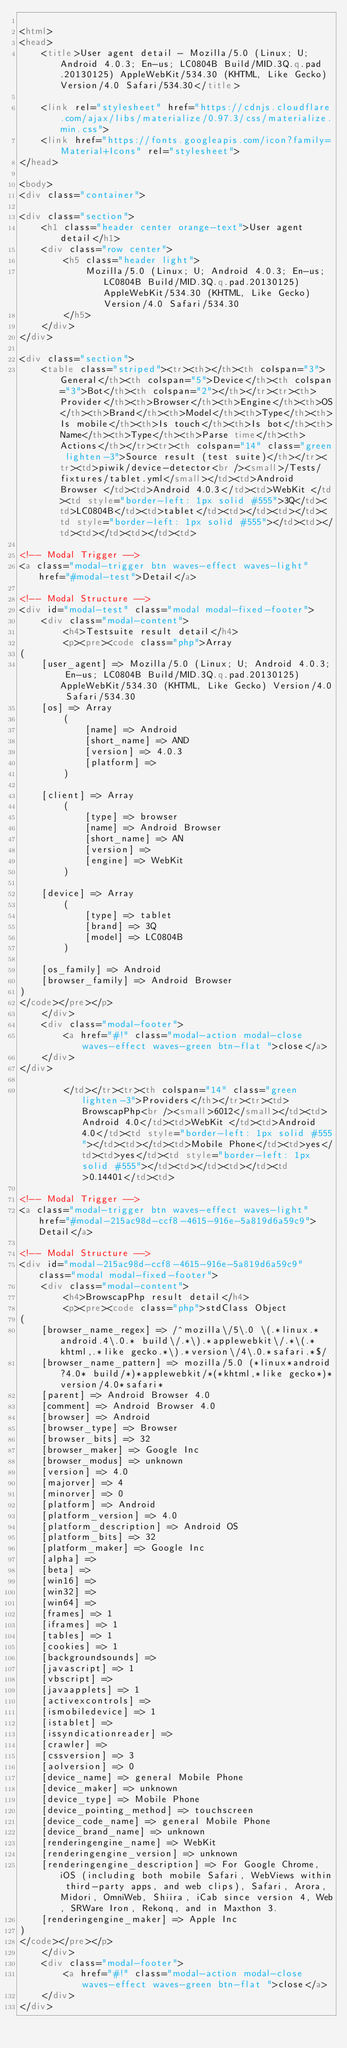<code> <loc_0><loc_0><loc_500><loc_500><_HTML_>
<html>
<head>
    <title>User agent detail - Mozilla/5.0 (Linux; U; Android 4.0.3; En-us; LC0804B Build/MID.3Q.q.pad.20130125) AppleWebKit/534.30 (KHTML, Like Gecko) Version/4.0 Safari/534.30</title>
        
    <link rel="stylesheet" href="https://cdnjs.cloudflare.com/ajax/libs/materialize/0.97.3/css/materialize.min.css">
    <link href="https://fonts.googleapis.com/icon?family=Material+Icons" rel="stylesheet">
</head>
        
<body>
<div class="container">
    
<div class="section">
	<h1 class="header center orange-text">User agent detail</h1>
	<div class="row center">
        <h5 class="header light">
            Mozilla/5.0 (Linux; U; Android 4.0.3; En-us; LC0804B Build/MID.3Q.q.pad.20130125) AppleWebKit/534.30 (KHTML, Like Gecko) Version/4.0 Safari/534.30
        </h5>
	</div>
</div>   

<div class="section">
    <table class="striped"><tr><th></th><th colspan="3">General</th><th colspan="5">Device</th><th colspan="3">Bot</th><th colspan="2"></th></tr><tr><th>Provider</th><th>Browser</th><th>Engine</th><th>OS</th><th>Brand</th><th>Model</th><th>Type</th><th>Is mobile</th><th>Is touch</th><th>Is bot</th><th>Name</th><th>Type</th><th>Parse time</th><th>Actions</th></tr><tr><th colspan="14" class="green lighten-3">Source result (test suite)</th></tr><tr><td>piwik/device-detector<br /><small>/Tests/fixtures/tablet.yml</small></td><td>Android Browser </td><td>Android 4.0.3</td><td>WebKit </td><td style="border-left: 1px solid #555">3Q</td><td>LC0804B</td><td>tablet</td><td></td><td></td><td style="border-left: 1px solid #555"></td><td></td><td></td><td></td><td>
                
<!-- Modal Trigger -->
<a class="modal-trigger btn waves-effect waves-light" href="#modal-test">Detail</a>

<!-- Modal Structure -->
<div id="modal-test" class="modal modal-fixed-footer">
    <div class="modal-content">
        <h4>Testsuite result detail</h4>
        <p><pre><code class="php">Array
(
    [user_agent] => Mozilla/5.0 (Linux; U; Android 4.0.3; En-us; LC0804B Build/MID.3Q.q.pad.20130125) AppleWebKit/534.30 (KHTML, Like Gecko) Version/4.0 Safari/534.30
    [os] => Array
        (
            [name] => Android
            [short_name] => AND
            [version] => 4.0.3
            [platform] => 
        )

    [client] => Array
        (
            [type] => browser
            [name] => Android Browser
            [short_name] => AN
            [version] => 
            [engine] => WebKit
        )

    [device] => Array
        (
            [type] => tablet
            [brand] => 3Q
            [model] => LC0804B
        )

    [os_family] => Android
    [browser_family] => Android Browser
)
</code></pre></p>
    </div>
    <div class="modal-footer">
        <a href="#!" class="modal-action modal-close waves-effect waves-green btn-flat ">close</a>
    </div>
</div>
                
        </td></tr><tr><th colspan="14" class="green lighten-3">Providers</th></tr><tr><td>BrowscapPhp<br /><small>6012</small></td><td>Android 4.0</td><td>WebKit </td><td>Android 4.0</td><td style="border-left: 1px solid #555"></td><td></td><td>Mobile Phone</td><td>yes</td><td>yes</td><td style="border-left: 1px solid #555"></td><td></td><td></td><td>0.14401</td><td>
                
<!-- Modal Trigger -->
<a class="modal-trigger btn waves-effect waves-light" href="#modal-215ac98d-ccf8-4615-916e-5a819d6a59c9">Detail</a>

<!-- Modal Structure -->
<div id="modal-215ac98d-ccf8-4615-916e-5a819d6a59c9" class="modal modal-fixed-footer">
    <div class="modal-content">
        <h4>BrowscapPhp result detail</h4>
        <p><pre><code class="php">stdClass Object
(
    [browser_name_regex] => /^mozilla\/5\.0 \(.*linux.*android.4\.0.* build\/.*\).*applewebkit\/.*\(.*khtml,.*like gecko.*\).*version\/4\.0.*safari.*$/
    [browser_name_pattern] => mozilla/5.0 (*linux*android?4.0* build/*)*applewebkit/*(*khtml,*like gecko*)*version/4.0*safari*
    [parent] => Android Browser 4.0
    [comment] => Android Browser 4.0
    [browser] => Android
    [browser_type] => Browser
    [browser_bits] => 32
    [browser_maker] => Google Inc
    [browser_modus] => unknown
    [version] => 4.0
    [majorver] => 4
    [minorver] => 0
    [platform] => Android
    [platform_version] => 4.0
    [platform_description] => Android OS
    [platform_bits] => 32
    [platform_maker] => Google Inc
    [alpha] => 
    [beta] => 
    [win16] => 
    [win32] => 
    [win64] => 
    [frames] => 1
    [iframes] => 1
    [tables] => 1
    [cookies] => 1
    [backgroundsounds] => 
    [javascript] => 1
    [vbscript] => 
    [javaapplets] => 1
    [activexcontrols] => 
    [ismobiledevice] => 1
    [istablet] => 
    [issyndicationreader] => 
    [crawler] => 
    [cssversion] => 3
    [aolversion] => 0
    [device_name] => general Mobile Phone
    [device_maker] => unknown
    [device_type] => Mobile Phone
    [device_pointing_method] => touchscreen
    [device_code_name] => general Mobile Phone
    [device_brand_name] => unknown
    [renderingengine_name] => WebKit
    [renderingengine_version] => unknown
    [renderingengine_description] => For Google Chrome, iOS (including both mobile Safari, WebViews within third-party apps, and web clips), Safari, Arora, Midori, OmniWeb, Shiira, iCab since version 4, Web, SRWare Iron, Rekonq, and in Maxthon 3.
    [renderingengine_maker] => Apple Inc
)
</code></pre></p>
    </div>
    <div class="modal-footer">
        <a href="#!" class="modal-action modal-close waves-effect waves-green btn-flat ">close</a>
    </div>
</div>
                </code> 